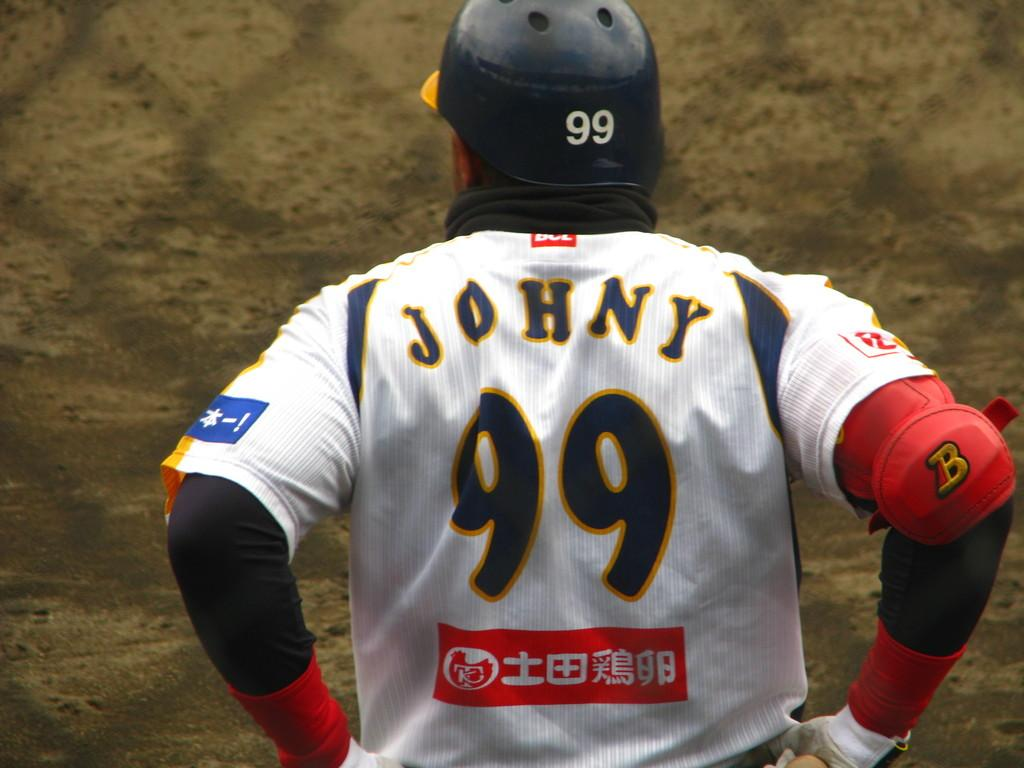What is the main subject of the image? There is a person in the image. What is the person doing in the image? The person is standing. What is the person wearing in the image? The person is wearing a helmet. Can you describe the background of the image? The background appears blurred. How many coughs can be heard in the image? There are no audible sounds in the image, so it is not possible to determine the number of coughs. 